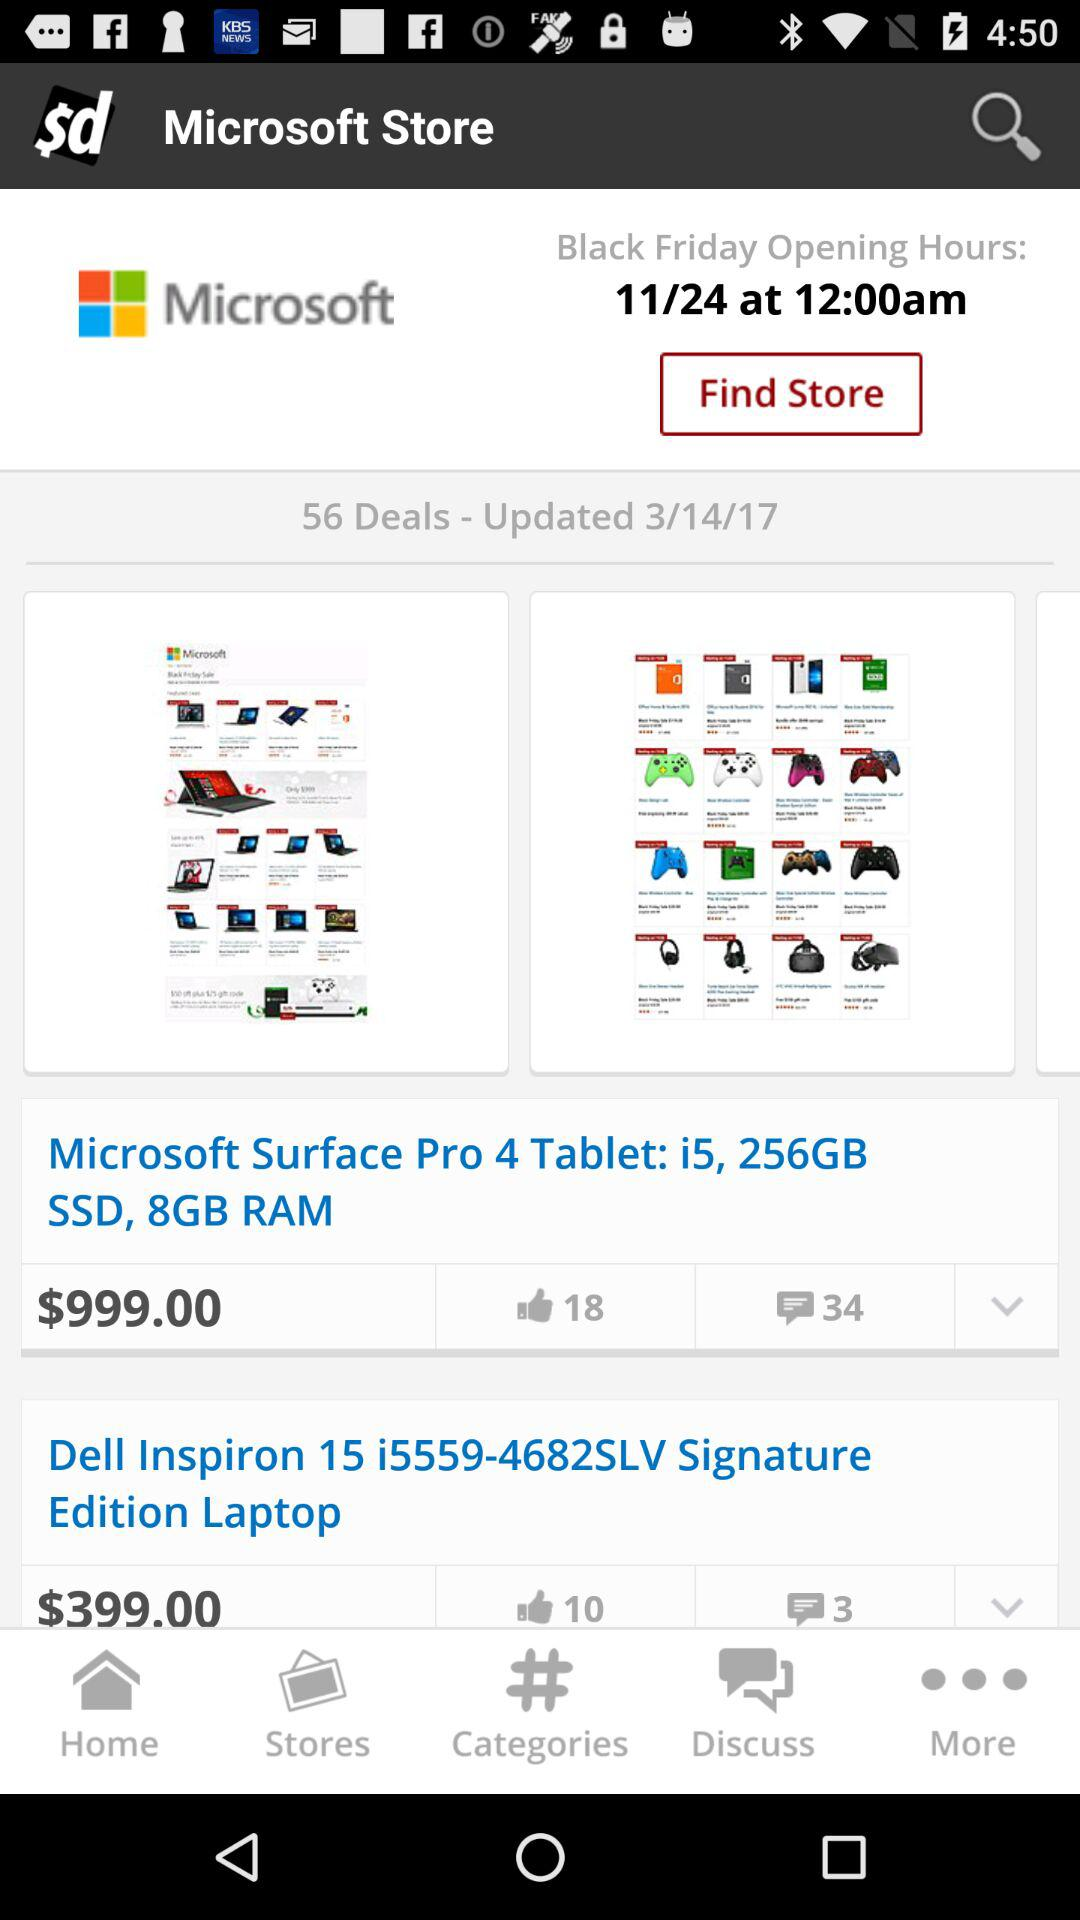What are the opening hours? The opening hours are 12:00 a.m. 